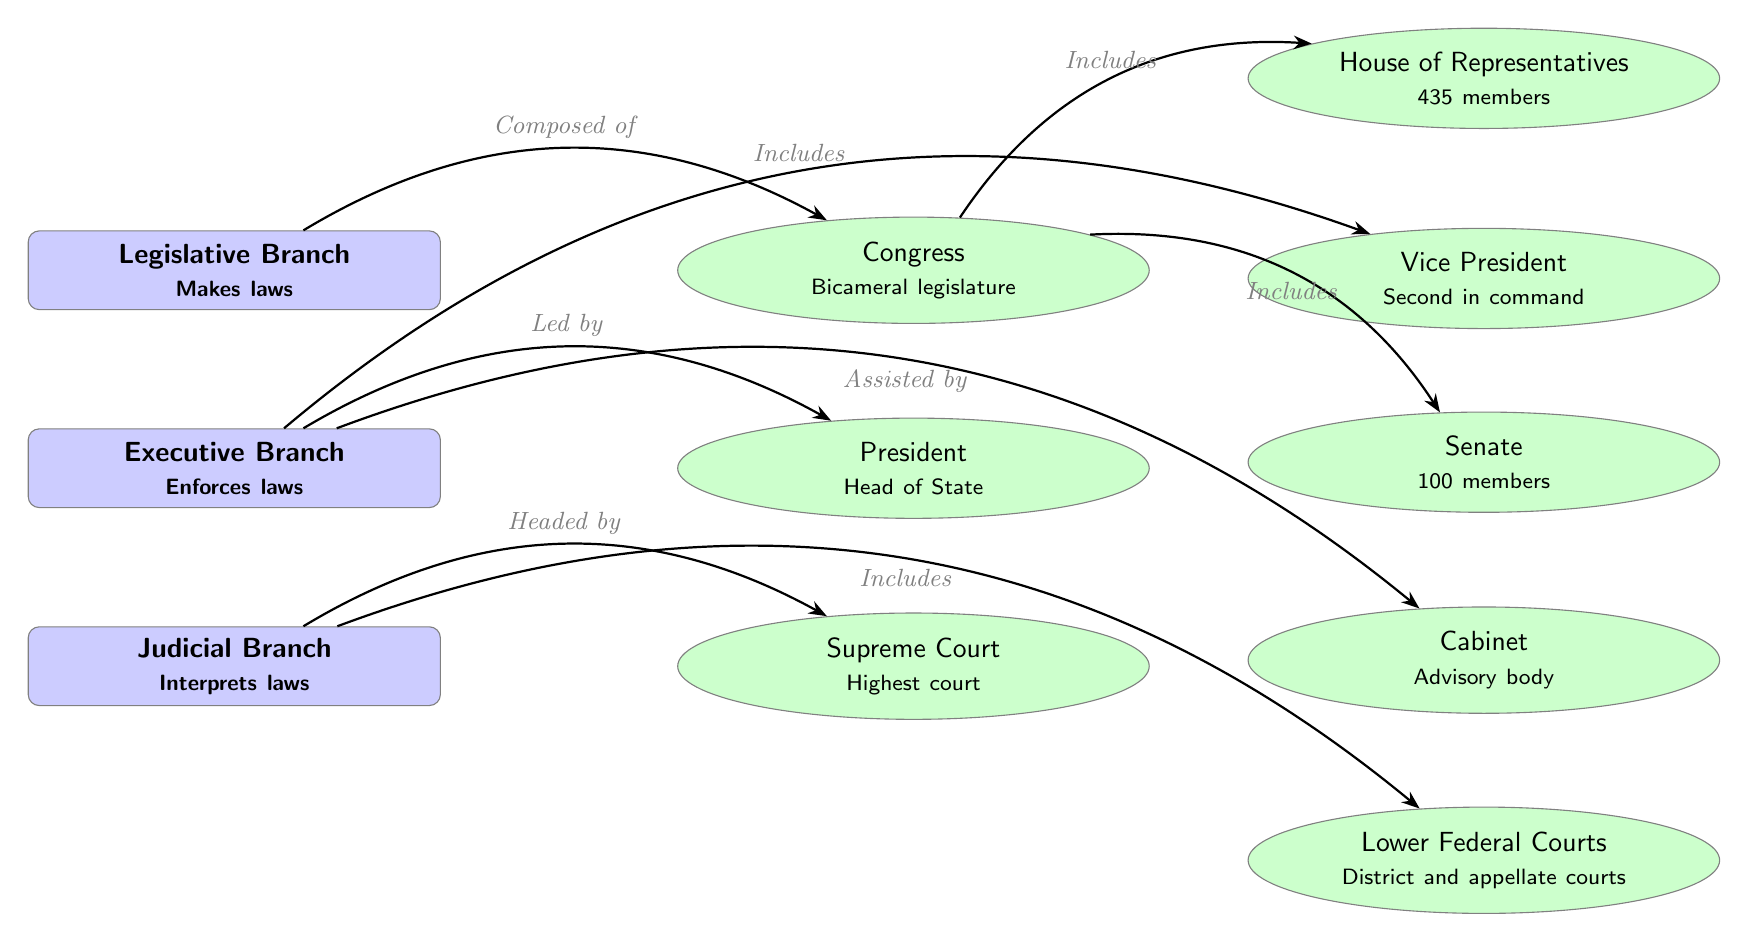What are the three branches of the United States Government? The diagram lists three branches: Legislative, Executive, and Judicial. These are clearly shown as the main branches at the top of the diagram.
Answer: Legislative, Executive, Judicial How many members are in the House of Representatives? The diagram specifies that there are 435 members in the House of Representatives. This information is explicitly stated in the subbranch connected to Congress.
Answer: 435 What is the primary function of the Legislative Branch? According to the diagram, the Legislative Branch is responsible for making laws, which is indicated directly beneath the title of the Legislative Branch.
Answer: Makes laws Who leads the Executive Branch? The diagram indicates that the President is the leader of the Executive Branch, as it is connected with an arrow from the Executive Branch to the President subbranch.
Answer: President How many members are in the Senate? The Senate, as indicated in the diagram, has 100 members, which is stated in the subbranch associated with the Senate.
Answer: 100 What body is considered the highest court in the United States? As per the diagram, the Supreme Court is identified as the highest court, noted in the subbranch connected to the Judicial Branch.
Answer: Supreme Court Which branch is responsible for interpreting laws? The diagram shows that the Judicial Branch has the role of interpreting laws, as indicated under the title of the Judicial Branch.
Answer: Judicial Branch What does the Cabinet provide to the Executive Branch? The diagram describes the Cabinet as an advisory body that assists the Executive Branch, which explains its role clearly in the subbranch of the Executive Branch.
Answer: Advisory body Which two bodies make up Congress? The diagram states that Congress is bicameral, consisting of the House of Representatives and the Senate. This relationship is delineated by arrows connecting Congress to each body.
Answer: House of Representatives, Senate What is the second in command in the Executive Branch? The Vice President is identified as the second in command, and this information is presented in the subbranch that connects to the Executive Branch.
Answer: Vice President 